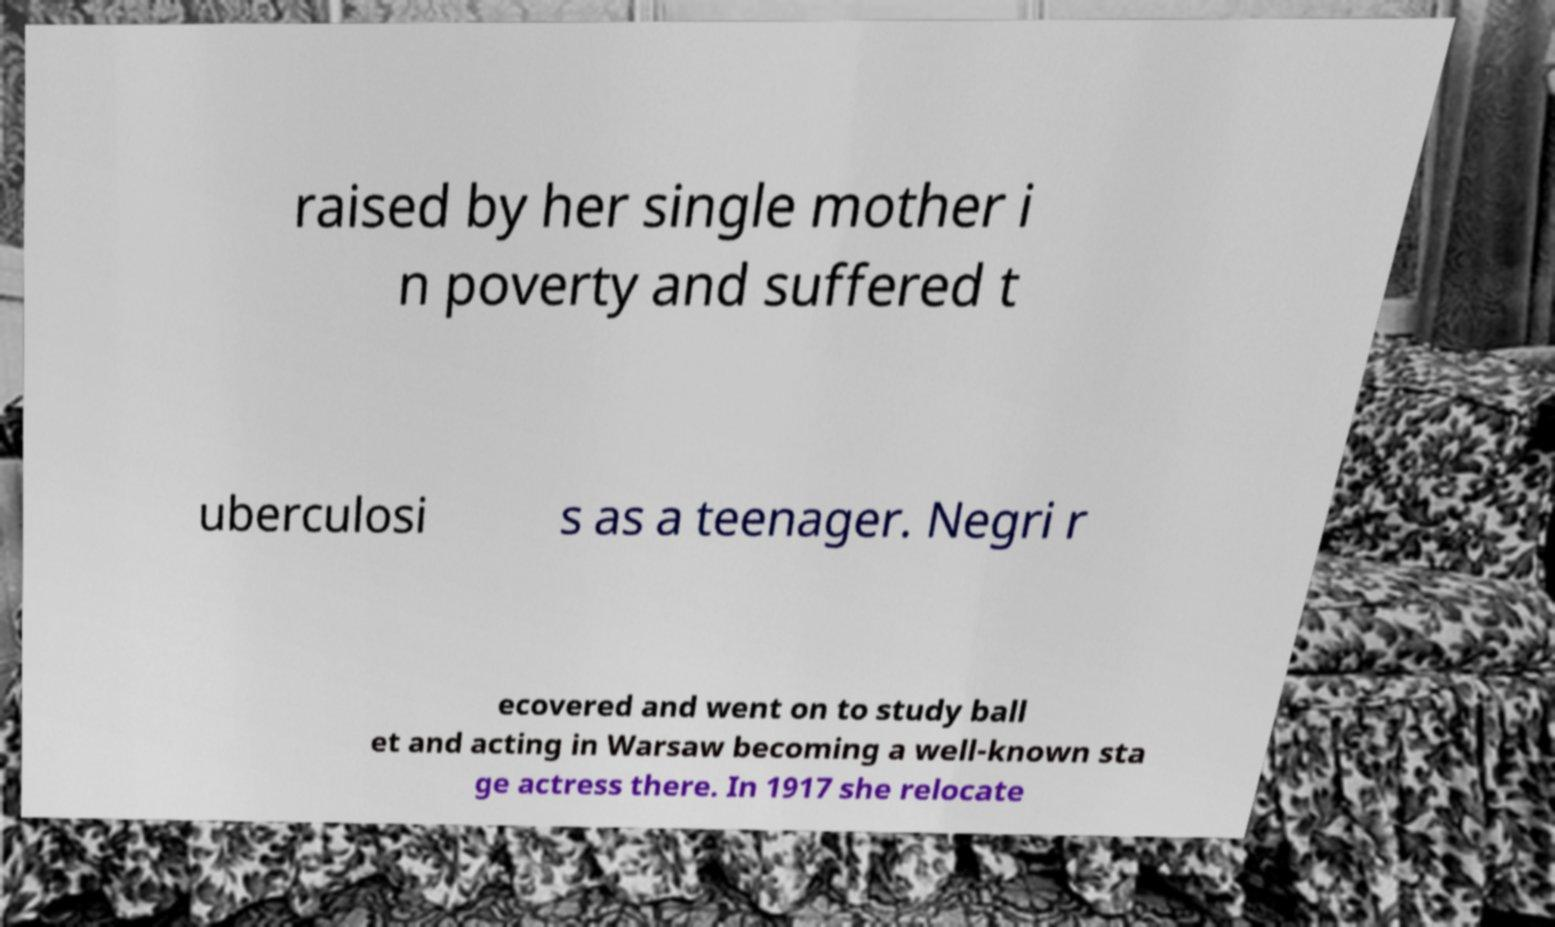Please read and relay the text visible in this image. What does it say? raised by her single mother i n poverty and suffered t uberculosi s as a teenager. Negri r ecovered and went on to study ball et and acting in Warsaw becoming a well-known sta ge actress there. In 1917 she relocate 